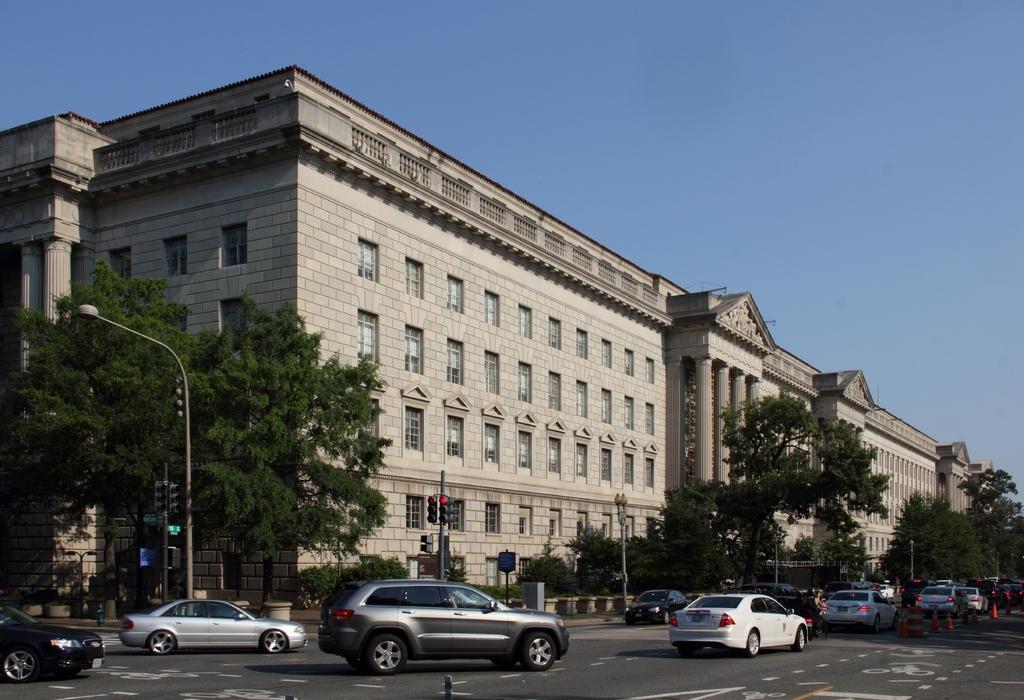Can you describe this image briefly? In this image in the center there are cars moving on the road. In the background there are trees, poles and there is a building and in front of the building, there are plants in the pots. On the right side there are red colour stands on the road. 